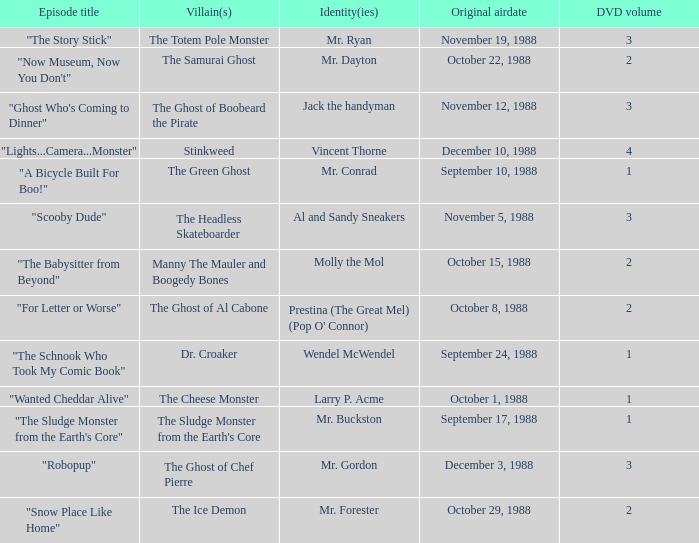Name the episode that aired october 8, 1988 "For Letter or Worse". 